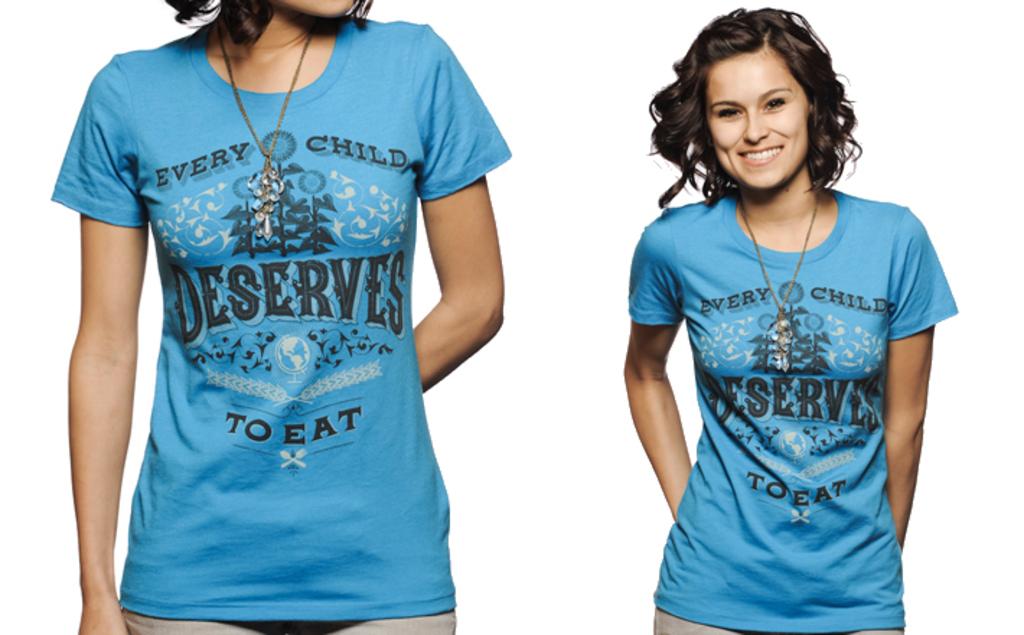What is the biggest word printed on the shirt?
Your answer should be compact. Deserves. Why is this person so concerned with children eating?
Offer a terse response. Unanswerable. 